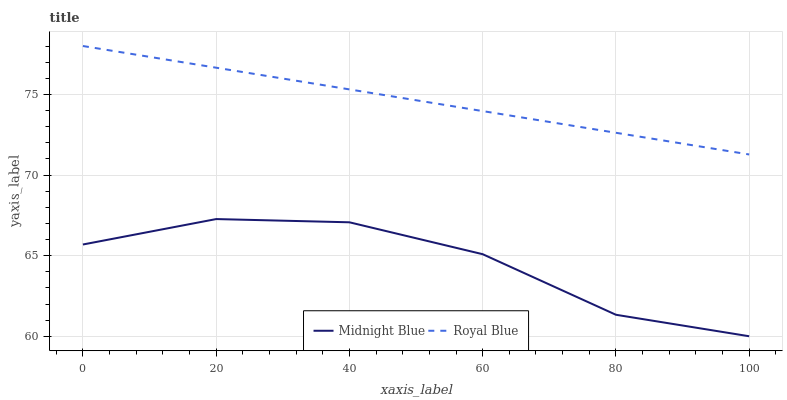Does Midnight Blue have the maximum area under the curve?
Answer yes or no. No. Is Midnight Blue the smoothest?
Answer yes or no. No. Does Midnight Blue have the highest value?
Answer yes or no. No. Is Midnight Blue less than Royal Blue?
Answer yes or no. Yes. Is Royal Blue greater than Midnight Blue?
Answer yes or no. Yes. Does Midnight Blue intersect Royal Blue?
Answer yes or no. No. 